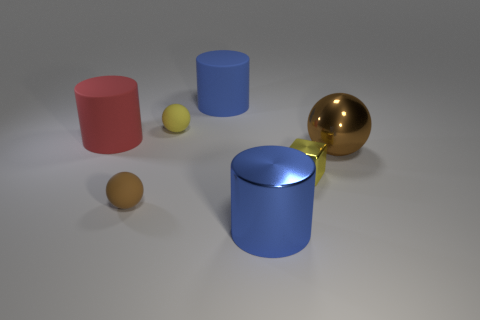Is there anything else that has the same shape as the yellow metallic object?
Keep it short and to the point. No. There is a cylinder that is on the left side of the tiny yellow thing that is behind the small yellow shiny thing; what color is it?
Your answer should be very brief. Red. What is the shape of the brown object that is the same size as the blue matte cylinder?
Give a very brief answer. Sphere. There is another thing that is the same color as the tiny shiny thing; what is its shape?
Provide a short and direct response. Sphere. Are there the same number of large objects that are on the left side of the brown shiny ball and blue metal blocks?
Keep it short and to the point. No. There is a small object that is behind the big rubber cylinder that is to the left of the matte sphere that is behind the yellow cube; what is its material?
Ensure brevity in your answer.  Rubber. What shape is the yellow thing that is the same material as the red cylinder?
Give a very brief answer. Sphere. Is there any other thing that has the same color as the tiny cube?
Your answer should be compact. Yes. How many big blue matte objects are behind the blue thing that is in front of the blue object to the left of the blue metal object?
Your answer should be compact. 1. How many blue things are either large things or metal things?
Keep it short and to the point. 2. 